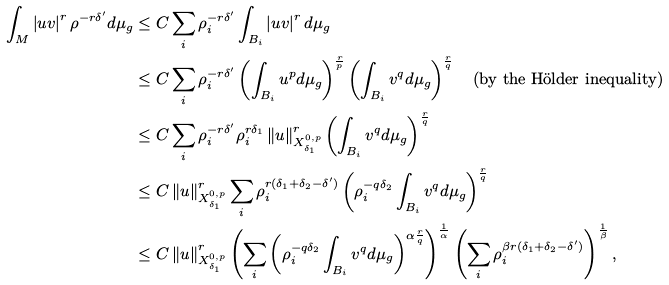Convert formula to latex. <formula><loc_0><loc_0><loc_500><loc_500>\int _ { M } \left | u v \right | ^ { r } \rho ^ { - r \delta ^ { \prime } } d \mu _ { g } & \leq C \sum _ { i } \rho _ { i } ^ { - r \delta ^ { \prime } } \int _ { B _ { i } } \left | u v \right | ^ { r } d \mu _ { g } \\ & \leq C \sum _ { i } \rho _ { i } ^ { - r \delta ^ { \prime } } \left ( \int _ { B _ { i } } u ^ { p } d \mu _ { g } \right ) ^ { \frac { r } { p } } \left ( \int _ { B _ { i } } v ^ { q } d \mu _ { g } \right ) ^ { \frac { r } { q } } \quad \text {(by the H\"older inequality)} \\ & \leq C \sum _ { i } \rho _ { i } ^ { - r \delta ^ { \prime } } \rho _ { i } ^ { r \delta _ { 1 } } \left \| u \right \| _ { X ^ { 0 , p } _ { \delta _ { 1 } } } ^ { r } \left ( \int _ { B _ { i } } v ^ { q } d \mu _ { g } \right ) ^ { \frac { r } { q } } \\ & \leq C \left \| u \right \| _ { X ^ { 0 , p } _ { \delta _ { 1 } } } ^ { r } \sum _ { i } \rho _ { i } ^ { r ( \delta _ { 1 } + \delta _ { 2 } - \delta ^ { \prime } ) } \left ( \rho _ { i } ^ { - q \delta _ { 2 } } \int _ { B _ { i } } v ^ { q } d \mu _ { g } \right ) ^ { \frac { r } { q } } \\ & \leq C \left \| u \right \| _ { X ^ { 0 , p } _ { \delta _ { 1 } } } ^ { r } \left ( \sum _ { i } \left ( \rho _ { i } ^ { - q \delta _ { 2 } } \int _ { B _ { i } } v ^ { q } d \mu _ { g } \right ) ^ { \alpha \frac { r } { q } } \right ) ^ { \frac { 1 } { \alpha } } \left ( \sum _ { i } \rho _ { i } ^ { \beta r ( \delta _ { 1 } + \delta _ { 2 } - \delta ^ { \prime } ) } \right ) ^ { \frac { 1 } { \beta } } ,</formula> 